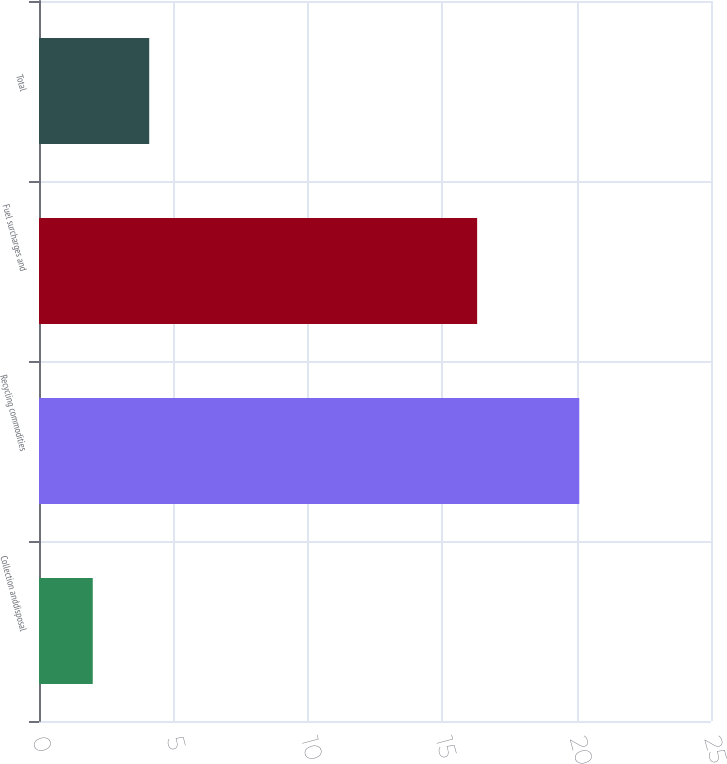Convert chart to OTSL. <chart><loc_0><loc_0><loc_500><loc_500><bar_chart><fcel>Collection anddisposal<fcel>Recycling commodities<fcel>Fuel surcharges and<fcel>Total<nl><fcel>2<fcel>20.1<fcel>16.3<fcel>4.1<nl></chart> 